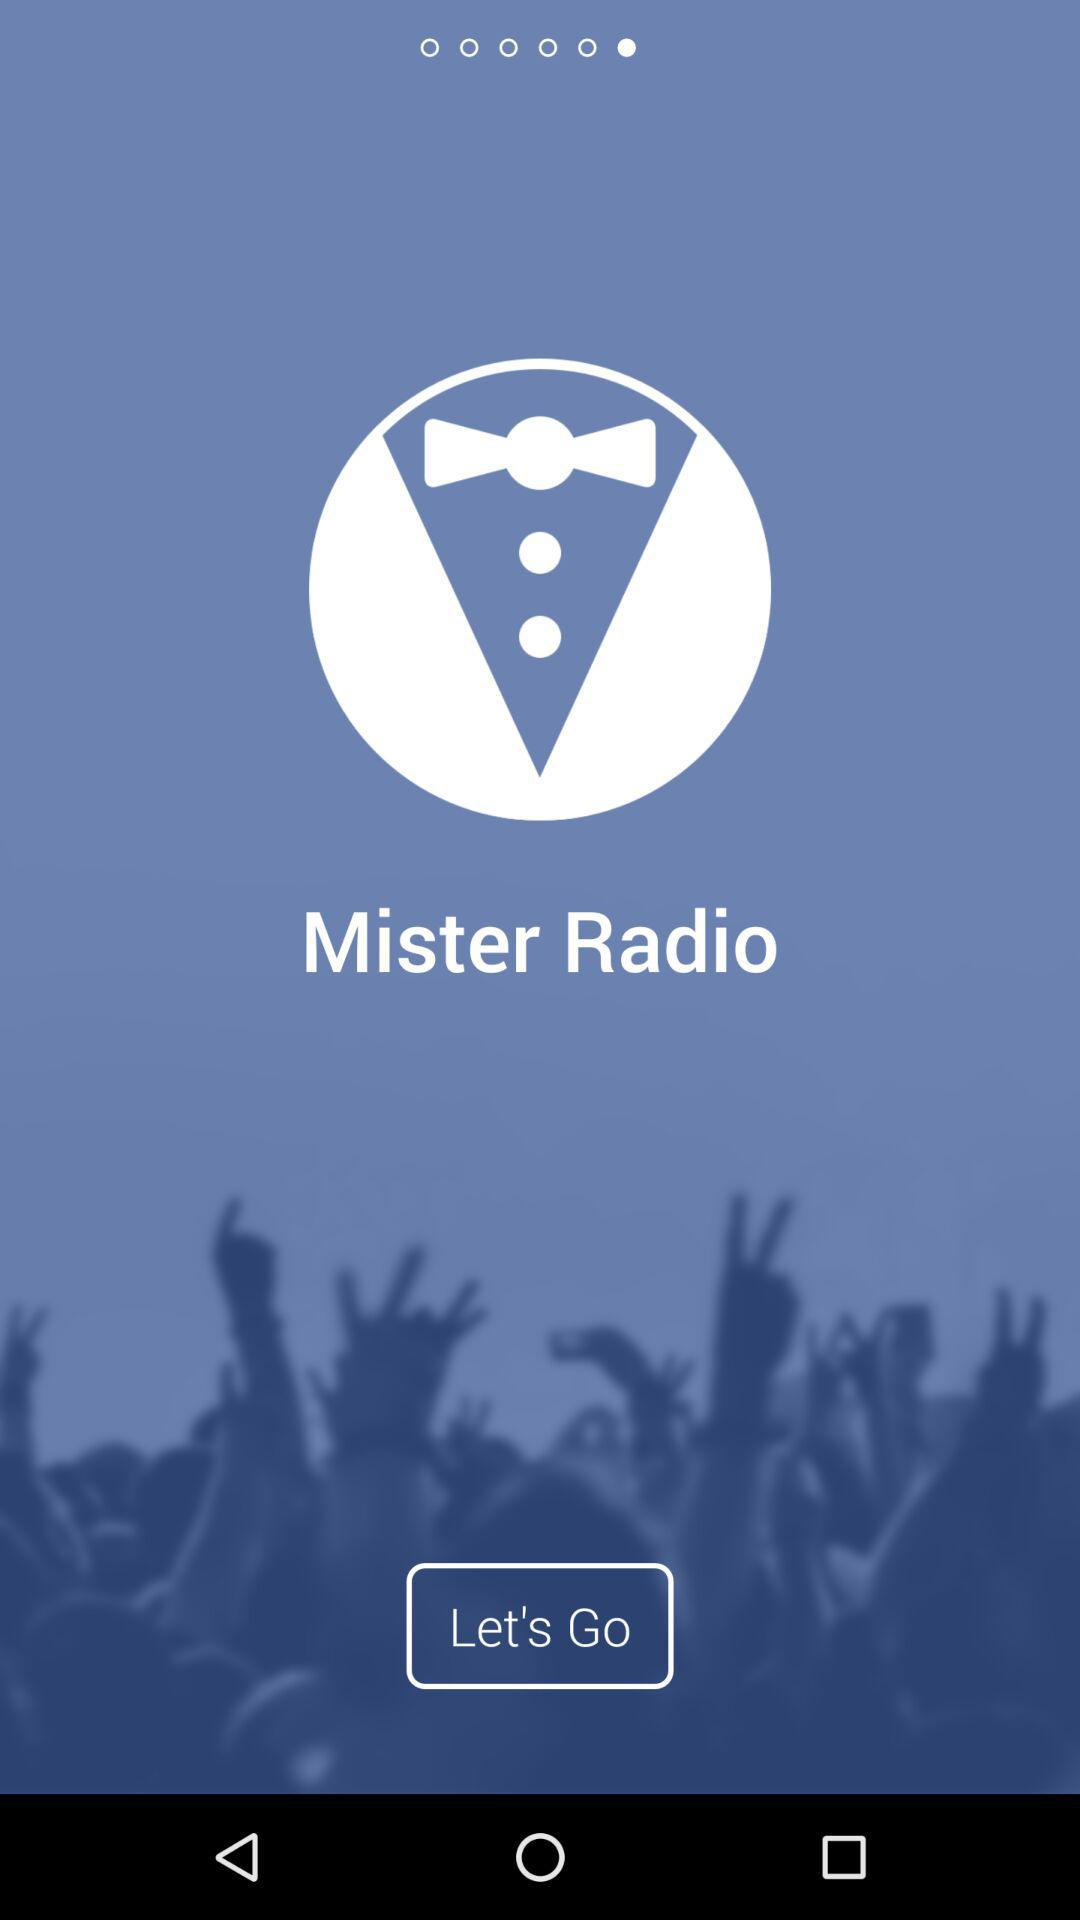What is the name of the application? The name of the application is "Mister Radio". 